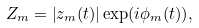Convert formula to latex. <formula><loc_0><loc_0><loc_500><loc_500>Z _ { m } = \left | z _ { m } ( t ) \right | \exp ( i \phi _ { m } ( t ) ) ,</formula> 